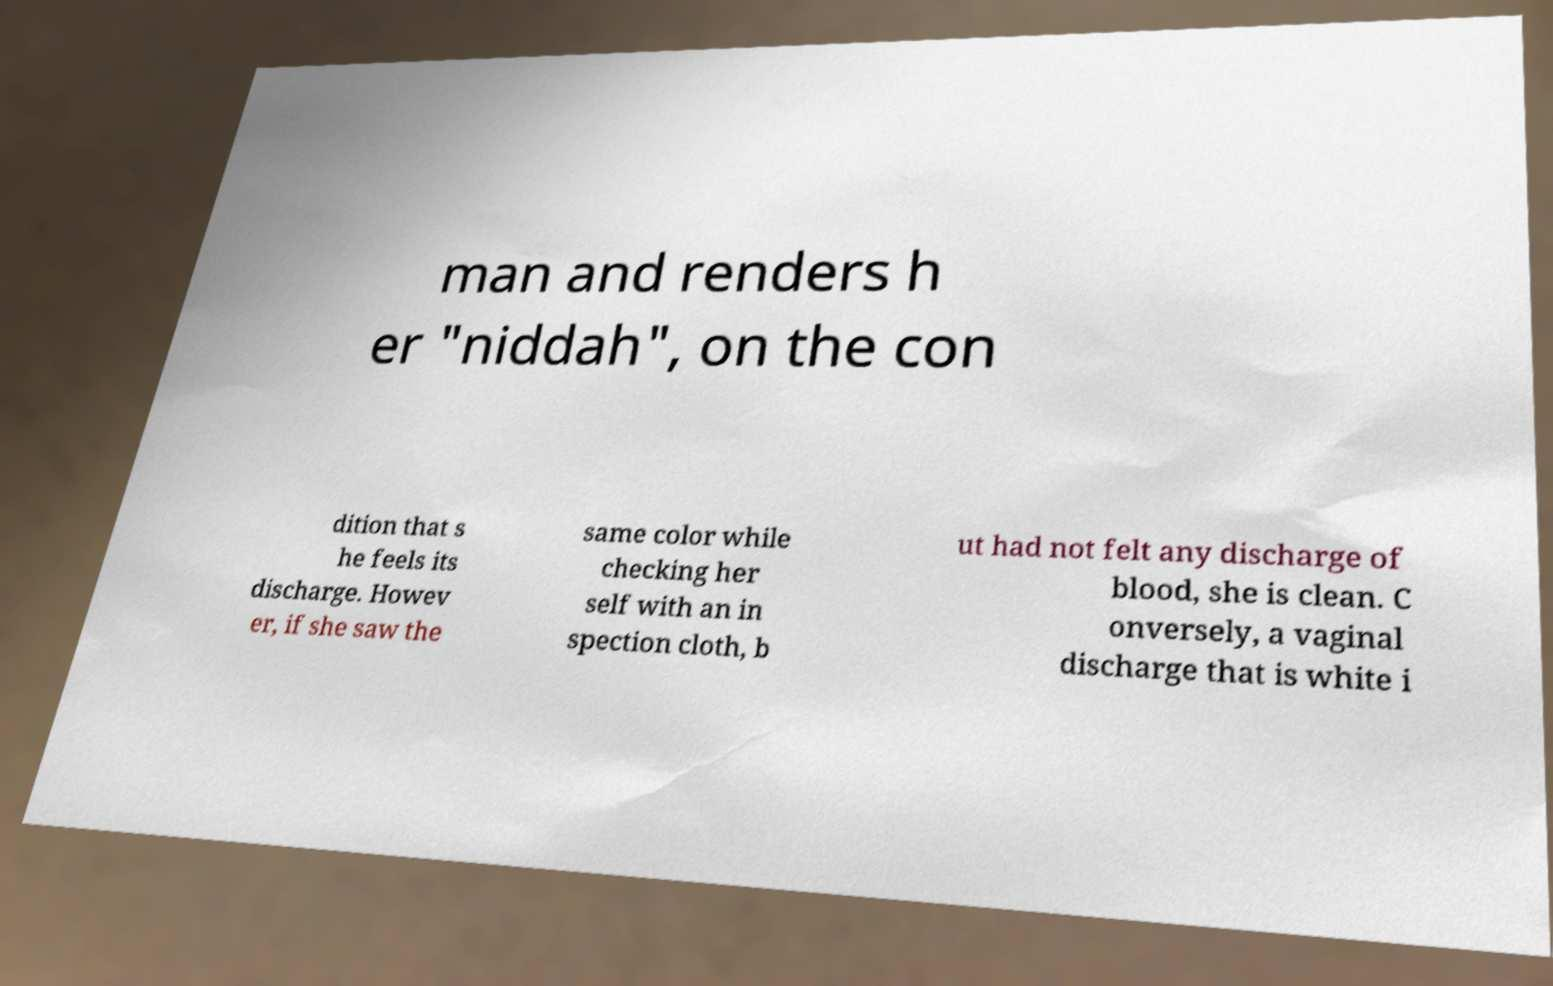Could you assist in decoding the text presented in this image and type it out clearly? man and renders h er "niddah", on the con dition that s he feels its discharge. Howev er, if she saw the same color while checking her self with an in spection cloth, b ut had not felt any discharge of blood, she is clean. C onversely, a vaginal discharge that is white i 